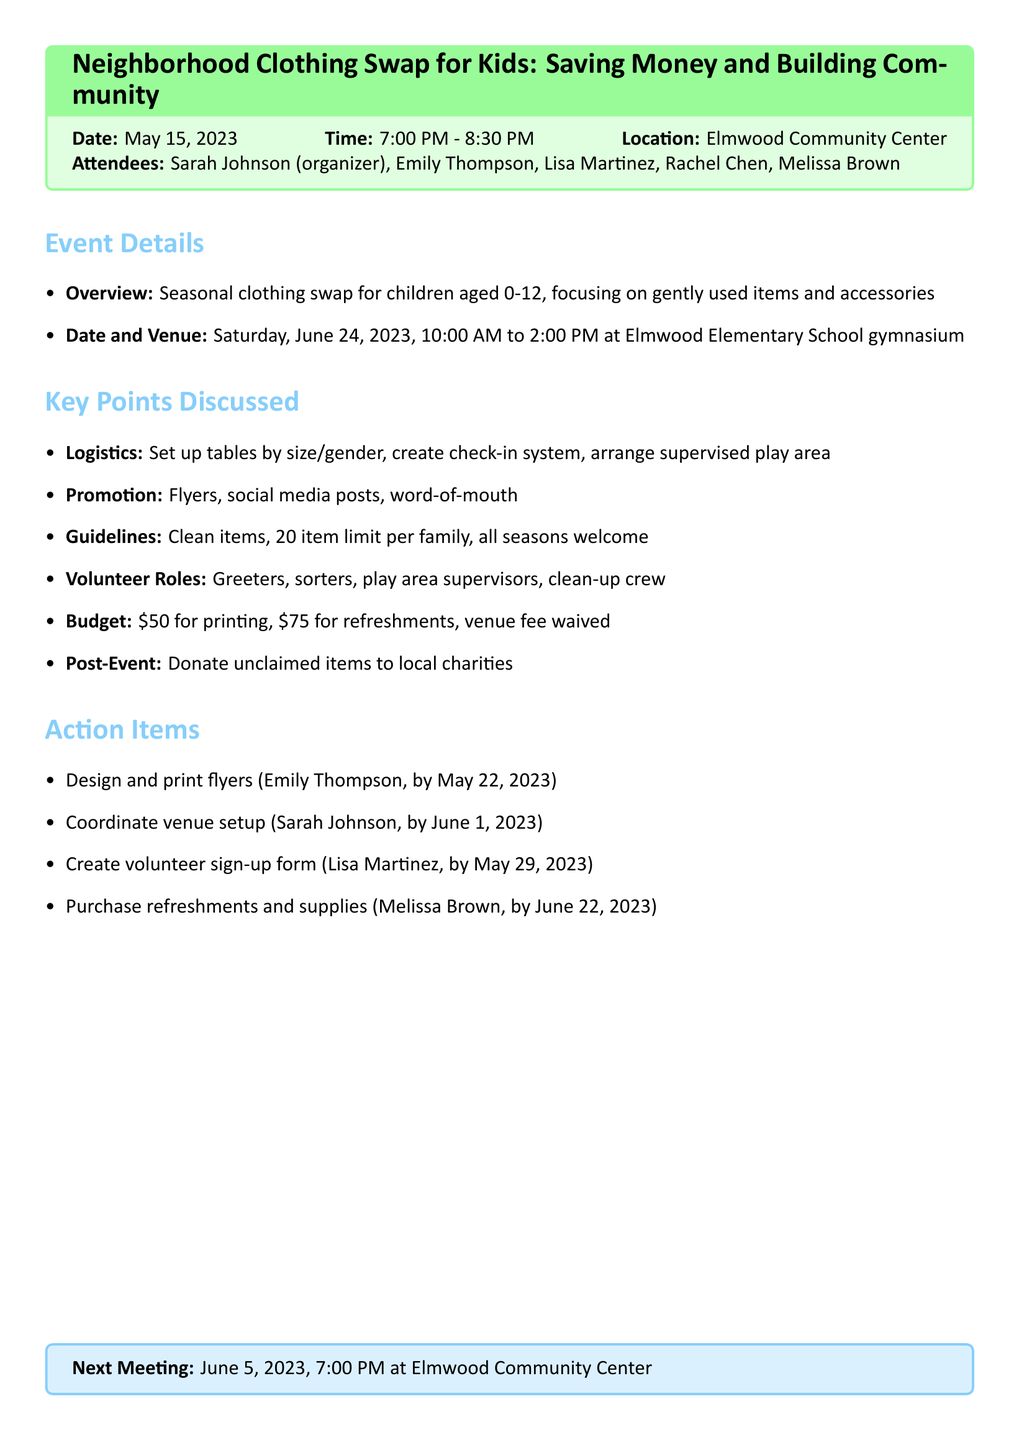what is the date of the clothing swap event? The date of the clothing swap event is mentioned as Saturday, June 24, 2023.
Answer: Saturday, June 24, 2023 who is the organizer of the event? The organizer of the event is listed in the attendees section as Sarah Johnson.
Answer: Sarah Johnson how many attendees were present at the meeting? The number of attendees can be counted from the list in the document, which includes five people.
Answer: five what is the budget allocated for refreshments? The budget item for refreshments states that the cost will be $75.
Answer: $75 what are the guidelines for participants regarding item condition? The guidelines specify that participants should bring clean, gently used items in good condition.
Answer: clean, gently used items in good condition why is the venue rental fee waived? The document states that the venue rental fee is waived by the school and a thank you note is required.
Answer: thank you note required what volunteer role involves supervising children? The specific role mentioned for supervising children is labeled as play area supervisors.
Answer: play area supervisors when is the next meeting scheduled? The document specifies that the next meeting is scheduled for June 5, 2023.
Answer: June 5, 2023 